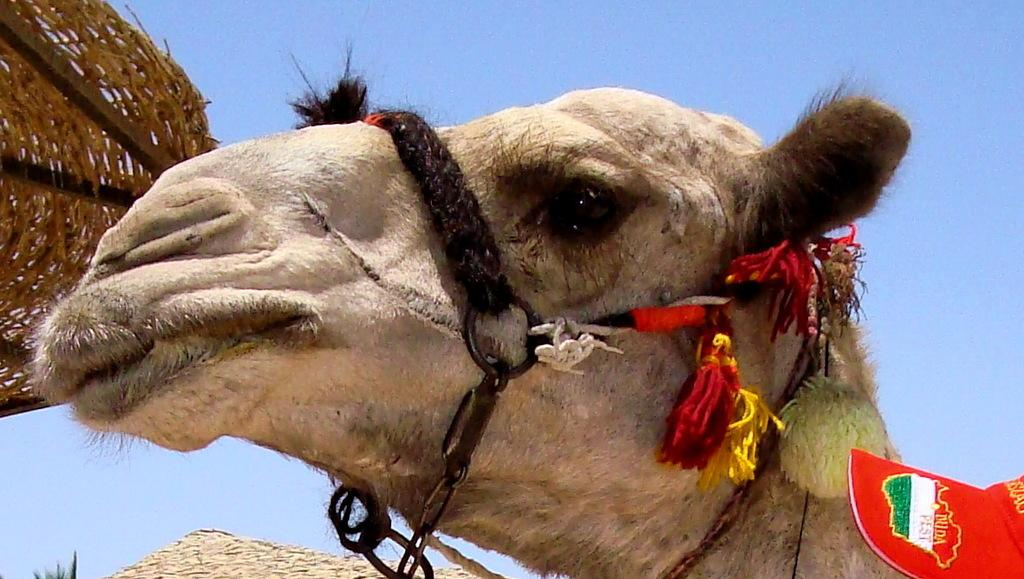What animal's head is visible in the image? The head of a camel is visible in the image. What is located behind the camel's face in the image? There is a basket behind the camel's face in the image. What type of structure is visible in the image? There is no structure visible in the image; it only features the head of a camel and a basket. What color is the family in the image? There is no family present in the image, so it is not possible to determine their color. 